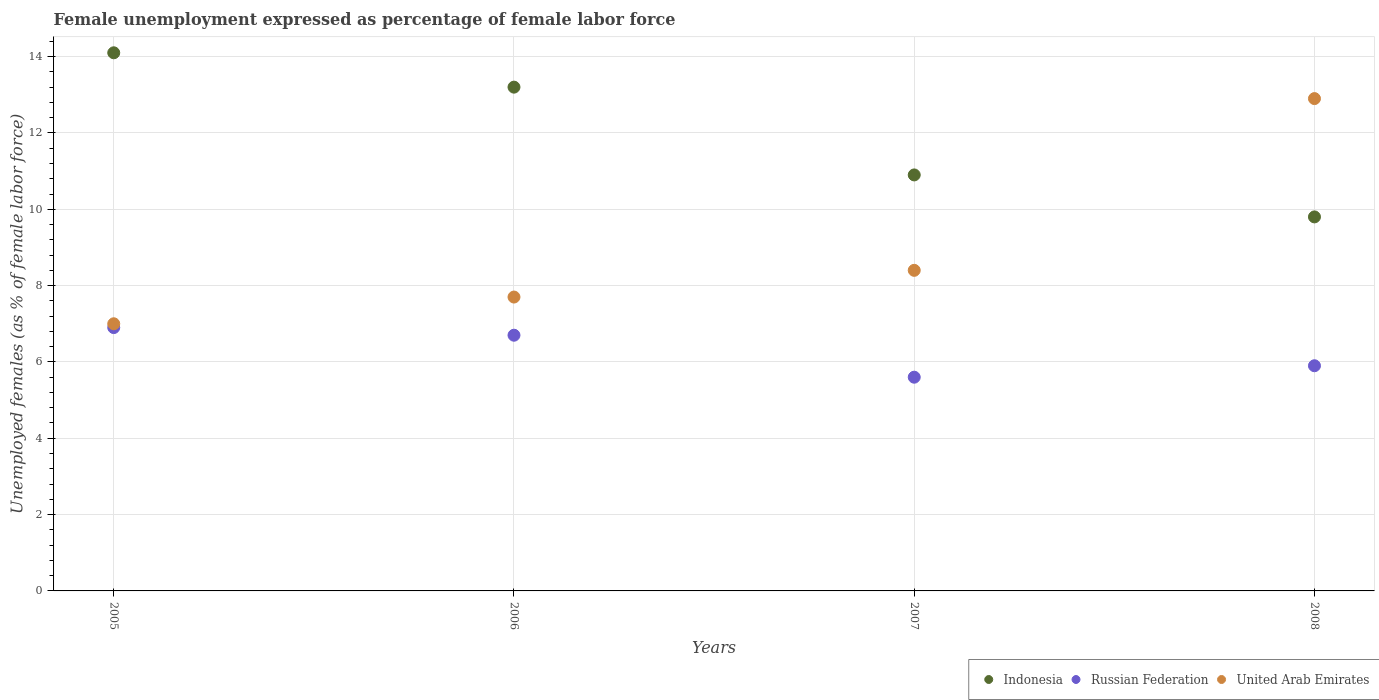Is the number of dotlines equal to the number of legend labels?
Your answer should be compact. Yes. What is the unemployment in females in in Indonesia in 2008?
Provide a short and direct response. 9.8. Across all years, what is the maximum unemployment in females in in Indonesia?
Offer a terse response. 14.1. Across all years, what is the minimum unemployment in females in in Indonesia?
Your response must be concise. 9.8. In which year was the unemployment in females in in United Arab Emirates maximum?
Your response must be concise. 2008. In which year was the unemployment in females in in United Arab Emirates minimum?
Offer a terse response. 2005. What is the total unemployment in females in in Indonesia in the graph?
Provide a short and direct response. 48. What is the difference between the unemployment in females in in Russian Federation in 2005 and the unemployment in females in in United Arab Emirates in 2007?
Provide a succinct answer. -1.5. What is the average unemployment in females in in Indonesia per year?
Offer a very short reply. 12. In how many years, is the unemployment in females in in United Arab Emirates greater than 6.8 %?
Make the answer very short. 4. What is the ratio of the unemployment in females in in Russian Federation in 2005 to that in 2007?
Your answer should be compact. 1.23. Is the unemployment in females in in Indonesia in 2005 less than that in 2006?
Provide a succinct answer. No. What is the difference between the highest and the second highest unemployment in females in in Russian Federation?
Make the answer very short. 0.2. What is the difference between the highest and the lowest unemployment in females in in Indonesia?
Provide a short and direct response. 4.3. Is the sum of the unemployment in females in in Russian Federation in 2005 and 2006 greater than the maximum unemployment in females in in United Arab Emirates across all years?
Make the answer very short. Yes. Is it the case that in every year, the sum of the unemployment in females in in Russian Federation and unemployment in females in in Indonesia  is greater than the unemployment in females in in United Arab Emirates?
Your answer should be very brief. Yes. Is the unemployment in females in in United Arab Emirates strictly less than the unemployment in females in in Indonesia over the years?
Offer a very short reply. No. How many dotlines are there?
Your answer should be very brief. 3. How many years are there in the graph?
Your answer should be compact. 4. Are the values on the major ticks of Y-axis written in scientific E-notation?
Offer a terse response. No. Does the graph contain any zero values?
Your answer should be compact. No. Does the graph contain grids?
Keep it short and to the point. Yes. Where does the legend appear in the graph?
Offer a terse response. Bottom right. How many legend labels are there?
Provide a short and direct response. 3. What is the title of the graph?
Your answer should be very brief. Female unemployment expressed as percentage of female labor force. Does "Chad" appear as one of the legend labels in the graph?
Give a very brief answer. No. What is the label or title of the Y-axis?
Your answer should be very brief. Unemployed females (as % of female labor force). What is the Unemployed females (as % of female labor force) in Indonesia in 2005?
Provide a short and direct response. 14.1. What is the Unemployed females (as % of female labor force) of Russian Federation in 2005?
Offer a very short reply. 6.9. What is the Unemployed females (as % of female labor force) of Indonesia in 2006?
Give a very brief answer. 13.2. What is the Unemployed females (as % of female labor force) in Russian Federation in 2006?
Your answer should be very brief. 6.7. What is the Unemployed females (as % of female labor force) of United Arab Emirates in 2006?
Keep it short and to the point. 7.7. What is the Unemployed females (as % of female labor force) of Indonesia in 2007?
Keep it short and to the point. 10.9. What is the Unemployed females (as % of female labor force) of Russian Federation in 2007?
Give a very brief answer. 5.6. What is the Unemployed females (as % of female labor force) of United Arab Emirates in 2007?
Keep it short and to the point. 8.4. What is the Unemployed females (as % of female labor force) of Indonesia in 2008?
Give a very brief answer. 9.8. What is the Unemployed females (as % of female labor force) in Russian Federation in 2008?
Provide a succinct answer. 5.9. What is the Unemployed females (as % of female labor force) in United Arab Emirates in 2008?
Your answer should be compact. 12.9. Across all years, what is the maximum Unemployed females (as % of female labor force) of Indonesia?
Ensure brevity in your answer.  14.1. Across all years, what is the maximum Unemployed females (as % of female labor force) of Russian Federation?
Give a very brief answer. 6.9. Across all years, what is the maximum Unemployed females (as % of female labor force) in United Arab Emirates?
Your response must be concise. 12.9. Across all years, what is the minimum Unemployed females (as % of female labor force) of Indonesia?
Provide a succinct answer. 9.8. Across all years, what is the minimum Unemployed females (as % of female labor force) of Russian Federation?
Ensure brevity in your answer.  5.6. Across all years, what is the minimum Unemployed females (as % of female labor force) of United Arab Emirates?
Your response must be concise. 7. What is the total Unemployed females (as % of female labor force) in Indonesia in the graph?
Your response must be concise. 48. What is the total Unemployed females (as % of female labor force) of Russian Federation in the graph?
Your response must be concise. 25.1. What is the difference between the Unemployed females (as % of female labor force) in Indonesia in 2005 and that in 2006?
Ensure brevity in your answer.  0.9. What is the difference between the Unemployed females (as % of female labor force) in United Arab Emirates in 2005 and that in 2006?
Keep it short and to the point. -0.7. What is the difference between the Unemployed females (as % of female labor force) of Russian Federation in 2005 and that in 2007?
Provide a succinct answer. 1.3. What is the difference between the Unemployed females (as % of female labor force) in United Arab Emirates in 2005 and that in 2007?
Provide a short and direct response. -1.4. What is the difference between the Unemployed females (as % of female labor force) in United Arab Emirates in 2005 and that in 2008?
Offer a very short reply. -5.9. What is the difference between the Unemployed females (as % of female labor force) of Indonesia in 2006 and that in 2007?
Offer a terse response. 2.3. What is the difference between the Unemployed females (as % of female labor force) in Russian Federation in 2006 and that in 2007?
Make the answer very short. 1.1. What is the difference between the Unemployed females (as % of female labor force) of United Arab Emirates in 2006 and that in 2007?
Offer a terse response. -0.7. What is the difference between the Unemployed females (as % of female labor force) of Russian Federation in 2007 and that in 2008?
Offer a terse response. -0.3. What is the difference between the Unemployed females (as % of female labor force) of Indonesia in 2005 and the Unemployed females (as % of female labor force) of Russian Federation in 2006?
Your answer should be compact. 7.4. What is the difference between the Unemployed females (as % of female labor force) of Indonesia in 2005 and the Unemployed females (as % of female labor force) of United Arab Emirates in 2006?
Offer a terse response. 6.4. What is the difference between the Unemployed females (as % of female labor force) of Russian Federation in 2005 and the Unemployed females (as % of female labor force) of United Arab Emirates in 2006?
Make the answer very short. -0.8. What is the difference between the Unemployed females (as % of female labor force) in Indonesia in 2005 and the Unemployed females (as % of female labor force) in Russian Federation in 2007?
Keep it short and to the point. 8.5. What is the difference between the Unemployed females (as % of female labor force) in Indonesia in 2005 and the Unemployed females (as % of female labor force) in United Arab Emirates in 2007?
Provide a succinct answer. 5.7. What is the difference between the Unemployed females (as % of female labor force) of Russian Federation in 2005 and the Unemployed females (as % of female labor force) of United Arab Emirates in 2007?
Your response must be concise. -1.5. What is the difference between the Unemployed females (as % of female labor force) in Indonesia in 2005 and the Unemployed females (as % of female labor force) in Russian Federation in 2008?
Provide a short and direct response. 8.2. What is the difference between the Unemployed females (as % of female labor force) of Indonesia in 2005 and the Unemployed females (as % of female labor force) of United Arab Emirates in 2008?
Your answer should be very brief. 1.2. What is the difference between the Unemployed females (as % of female labor force) in Russian Federation in 2005 and the Unemployed females (as % of female labor force) in United Arab Emirates in 2008?
Keep it short and to the point. -6. What is the difference between the Unemployed females (as % of female labor force) of Indonesia in 2006 and the Unemployed females (as % of female labor force) of Russian Federation in 2007?
Make the answer very short. 7.6. What is the difference between the Unemployed females (as % of female labor force) of Indonesia in 2006 and the Unemployed females (as % of female labor force) of Russian Federation in 2008?
Your answer should be very brief. 7.3. What is the difference between the Unemployed females (as % of female labor force) in Russian Federation in 2006 and the Unemployed females (as % of female labor force) in United Arab Emirates in 2008?
Keep it short and to the point. -6.2. What is the difference between the Unemployed females (as % of female labor force) of Russian Federation in 2007 and the Unemployed females (as % of female labor force) of United Arab Emirates in 2008?
Offer a very short reply. -7.3. What is the average Unemployed females (as % of female labor force) in Indonesia per year?
Your response must be concise. 12. What is the average Unemployed females (as % of female labor force) of Russian Federation per year?
Your response must be concise. 6.28. In the year 2005, what is the difference between the Unemployed females (as % of female labor force) of Russian Federation and Unemployed females (as % of female labor force) of United Arab Emirates?
Your answer should be very brief. -0.1. In the year 2006, what is the difference between the Unemployed females (as % of female labor force) of Indonesia and Unemployed females (as % of female labor force) of Russian Federation?
Ensure brevity in your answer.  6.5. In the year 2006, what is the difference between the Unemployed females (as % of female labor force) in Indonesia and Unemployed females (as % of female labor force) in United Arab Emirates?
Offer a very short reply. 5.5. In the year 2006, what is the difference between the Unemployed females (as % of female labor force) of Russian Federation and Unemployed females (as % of female labor force) of United Arab Emirates?
Offer a very short reply. -1. In the year 2007, what is the difference between the Unemployed females (as % of female labor force) of Indonesia and Unemployed females (as % of female labor force) of Russian Federation?
Make the answer very short. 5.3. In the year 2007, what is the difference between the Unemployed females (as % of female labor force) in Indonesia and Unemployed females (as % of female labor force) in United Arab Emirates?
Your answer should be very brief. 2.5. In the year 2007, what is the difference between the Unemployed females (as % of female labor force) of Russian Federation and Unemployed females (as % of female labor force) of United Arab Emirates?
Provide a succinct answer. -2.8. In the year 2008, what is the difference between the Unemployed females (as % of female labor force) of Russian Federation and Unemployed females (as % of female labor force) of United Arab Emirates?
Give a very brief answer. -7. What is the ratio of the Unemployed females (as % of female labor force) in Indonesia in 2005 to that in 2006?
Ensure brevity in your answer.  1.07. What is the ratio of the Unemployed females (as % of female labor force) of Russian Federation in 2005 to that in 2006?
Your answer should be very brief. 1.03. What is the ratio of the Unemployed females (as % of female labor force) in Indonesia in 2005 to that in 2007?
Your answer should be compact. 1.29. What is the ratio of the Unemployed females (as % of female labor force) of Russian Federation in 2005 to that in 2007?
Offer a very short reply. 1.23. What is the ratio of the Unemployed females (as % of female labor force) of Indonesia in 2005 to that in 2008?
Ensure brevity in your answer.  1.44. What is the ratio of the Unemployed females (as % of female labor force) in Russian Federation in 2005 to that in 2008?
Your response must be concise. 1.17. What is the ratio of the Unemployed females (as % of female labor force) of United Arab Emirates in 2005 to that in 2008?
Keep it short and to the point. 0.54. What is the ratio of the Unemployed females (as % of female labor force) of Indonesia in 2006 to that in 2007?
Ensure brevity in your answer.  1.21. What is the ratio of the Unemployed females (as % of female labor force) in Russian Federation in 2006 to that in 2007?
Ensure brevity in your answer.  1.2. What is the ratio of the Unemployed females (as % of female labor force) in Indonesia in 2006 to that in 2008?
Provide a short and direct response. 1.35. What is the ratio of the Unemployed females (as % of female labor force) in Russian Federation in 2006 to that in 2008?
Your answer should be very brief. 1.14. What is the ratio of the Unemployed females (as % of female labor force) in United Arab Emirates in 2006 to that in 2008?
Keep it short and to the point. 0.6. What is the ratio of the Unemployed females (as % of female labor force) in Indonesia in 2007 to that in 2008?
Offer a very short reply. 1.11. What is the ratio of the Unemployed females (as % of female labor force) of Russian Federation in 2007 to that in 2008?
Your answer should be very brief. 0.95. What is the ratio of the Unemployed females (as % of female labor force) of United Arab Emirates in 2007 to that in 2008?
Your answer should be compact. 0.65. What is the difference between the highest and the lowest Unemployed females (as % of female labor force) of United Arab Emirates?
Ensure brevity in your answer.  5.9. 